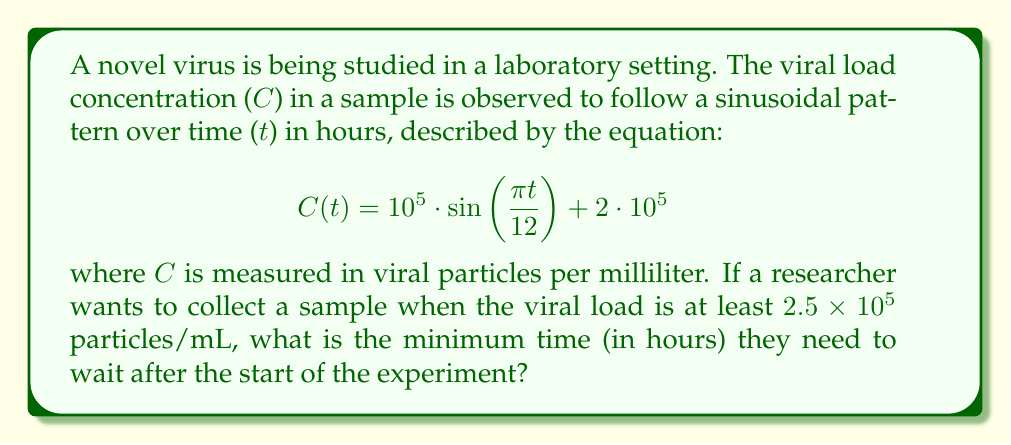What is the answer to this math problem? Let's approach this step-by-step:

1) We need to find t when C(t) ≥ 2.5 × 10^5

2) Set up the inequality:
   $$ 10^5 \cdot \sin\left(\frac{\pi t}{12}\right) + 2 \cdot 10^5 \geq 2.5 \cdot 10^5 $$

3) Subtract 2 × 10^5 from both sides:
   $$ 10^5 \cdot \sin\left(\frac{\pi t}{12}\right) \geq 0.5 \cdot 10^5 $$

4) Divide both sides by 10^5:
   $$ \sin\left(\frac{\pi t}{12}\right) \geq 0.5 $$

5) Apply arcsin (inverse sine) to both sides:
   $$ \frac{\pi t}{12} \geq \arcsin(0.5) $$

6) Multiply both sides by 12/π:
   $$ t \geq \frac{12}{\pi} \cdot \arcsin(0.5) $$

7) Calculate:
   $$ t \geq \frac{12}{\pi} \cdot 0.5235988 \approx 2 $$

Therefore, the researcher needs to wait at least 2 hours after the start of the experiment.
Answer: 2 hours 